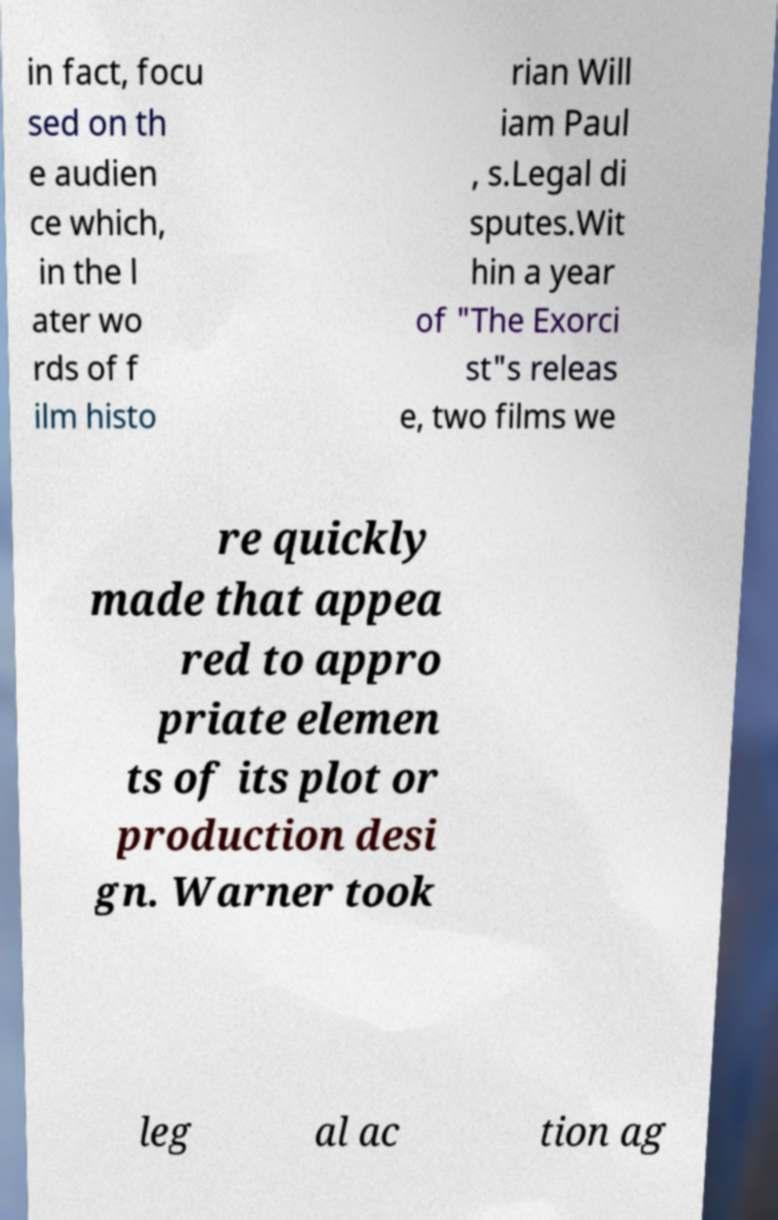Can you read and provide the text displayed in the image?This photo seems to have some interesting text. Can you extract and type it out for me? in fact, focu sed on th e audien ce which, in the l ater wo rds of f ilm histo rian Will iam Paul , s.Legal di sputes.Wit hin a year of "The Exorci st"s releas e, two films we re quickly made that appea red to appro priate elemen ts of its plot or production desi gn. Warner took leg al ac tion ag 